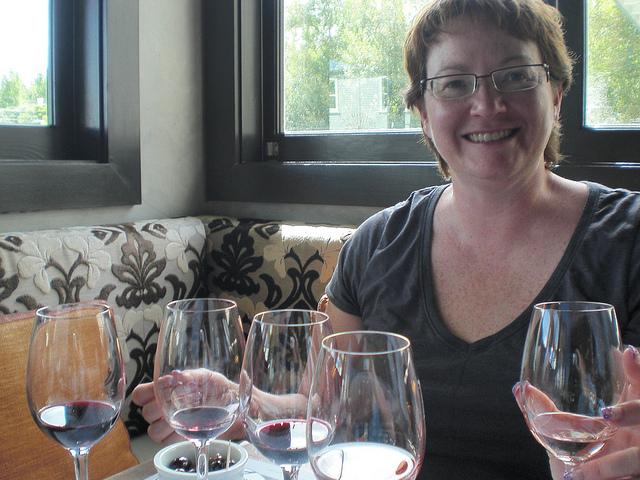What is on her face?
Short answer required. Glasses. What is she holding?
Quick response, please. Wine glass. What color is the wine?
Quick response, please. Red. How long has the man been judging Wine?
Answer briefly. 5 years. What is she drinking?
Answer briefly. Wine. 